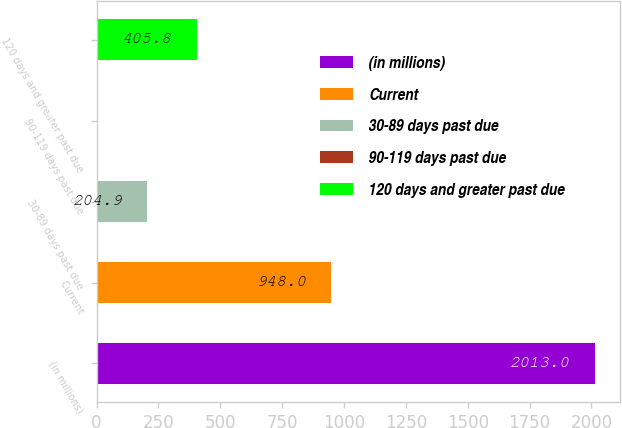Convert chart. <chart><loc_0><loc_0><loc_500><loc_500><bar_chart><fcel>(in millions)<fcel>Current<fcel>30-89 days past due<fcel>90-119 days past due<fcel>120 days and greater past due<nl><fcel>2013<fcel>948<fcel>204.9<fcel>4<fcel>405.8<nl></chart> 